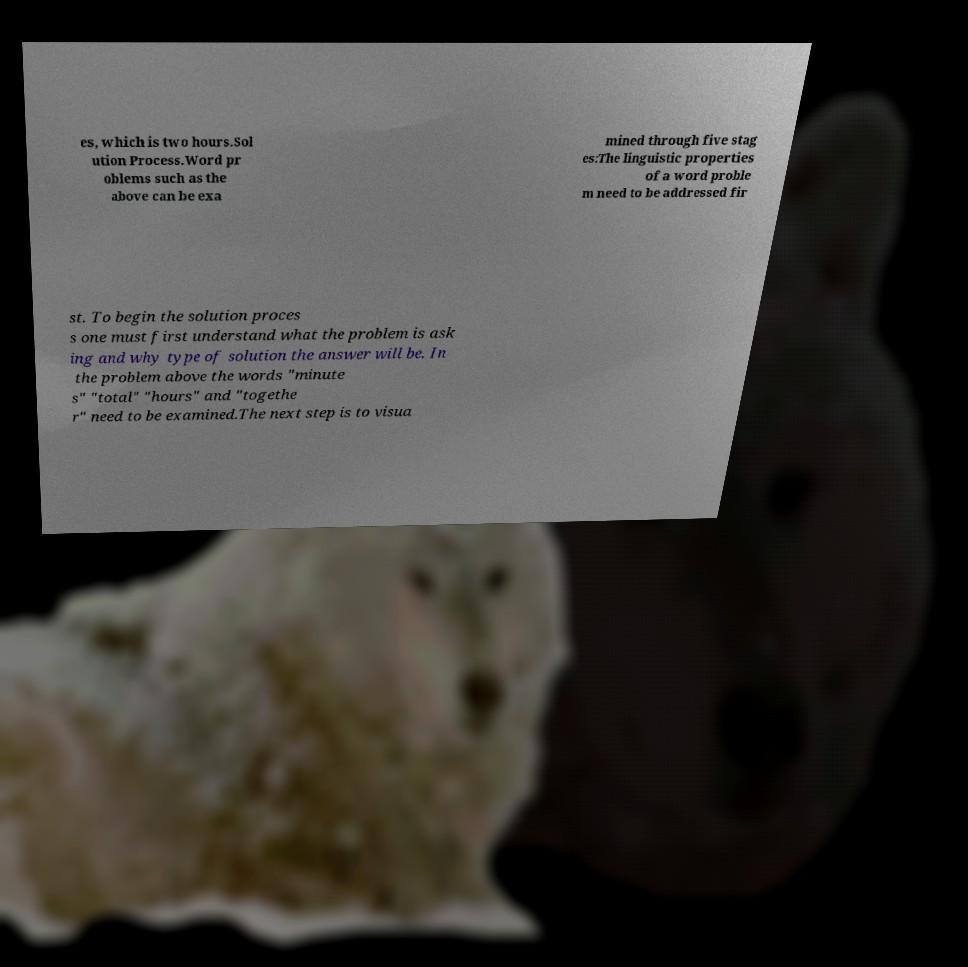For documentation purposes, I need the text within this image transcribed. Could you provide that? es, which is two hours.Sol ution Process.Word pr oblems such as the above can be exa mined through five stag es:The linguistic properties of a word proble m need to be addressed fir st. To begin the solution proces s one must first understand what the problem is ask ing and why type of solution the answer will be. In the problem above the words "minute s" "total" "hours" and "togethe r" need to be examined.The next step is to visua 